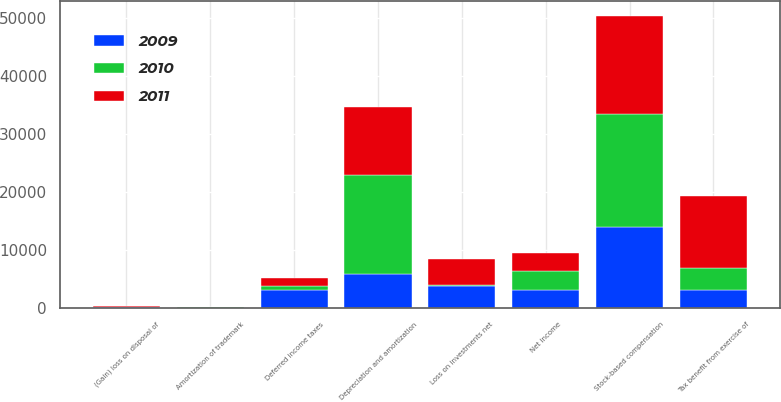<chart> <loc_0><loc_0><loc_500><loc_500><stacked_bar_chart><ecel><fcel>Net income<fcel>Amortization of trademark<fcel>Depreciation and amortization<fcel>(Gain) loss on disposal of<fcel>Stock-based compensation<fcel>Loss on investments net<fcel>Deferred income taxes<fcel>Tax benefit from exercise of<nl><fcel>2010<fcel>3163<fcel>52<fcel>17032<fcel>18<fcel>19424<fcel>43<fcel>687<fcel>3824<nl><fcel>2011<fcel>3163<fcel>48<fcel>11728<fcel>194<fcel>16862<fcel>4526<fcel>1361<fcel>12374<nl><fcel>2009<fcel>3163<fcel>68<fcel>5839<fcel>144<fcel>14040<fcel>3887<fcel>3163<fcel>3131<nl></chart> 